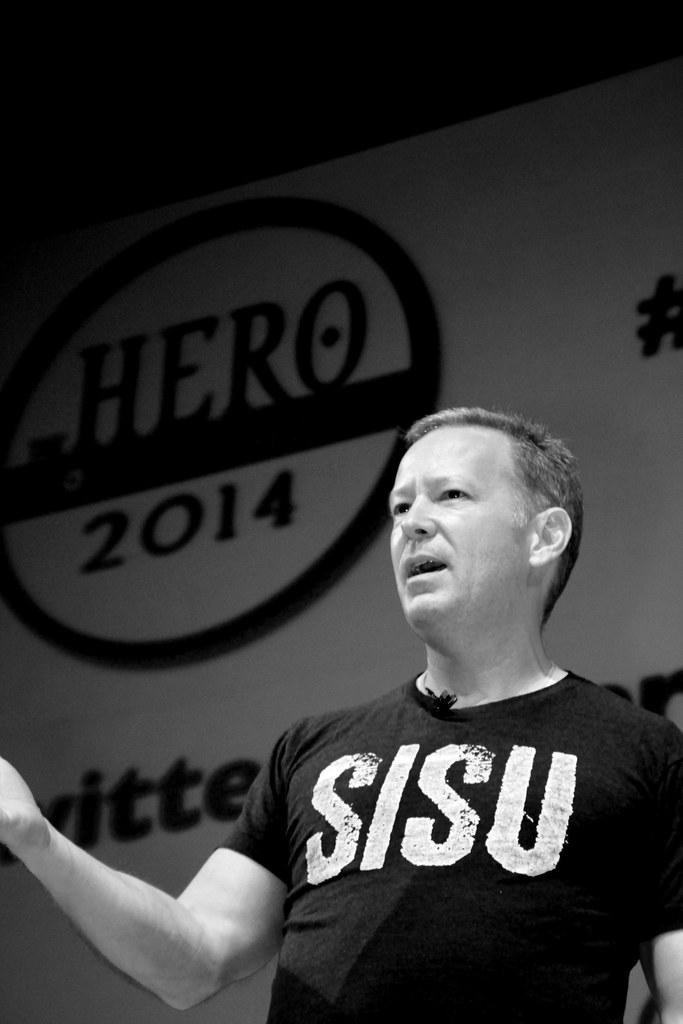<image>
Render a clear and concise summary of the photo. A black and white photo of a man giving a speech in front of a sign that says HERO 2014. 